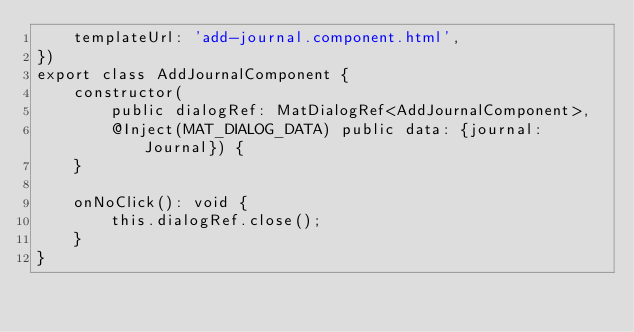<code> <loc_0><loc_0><loc_500><loc_500><_TypeScript_>    templateUrl: 'add-journal.component.html',
})
export class AddJournalComponent {
    constructor(
        public dialogRef: MatDialogRef<AddJournalComponent>,
        @Inject(MAT_DIALOG_DATA) public data: {journal: Journal}) {
    }

    onNoClick(): void {
        this.dialogRef.close();
    }
}

</code> 